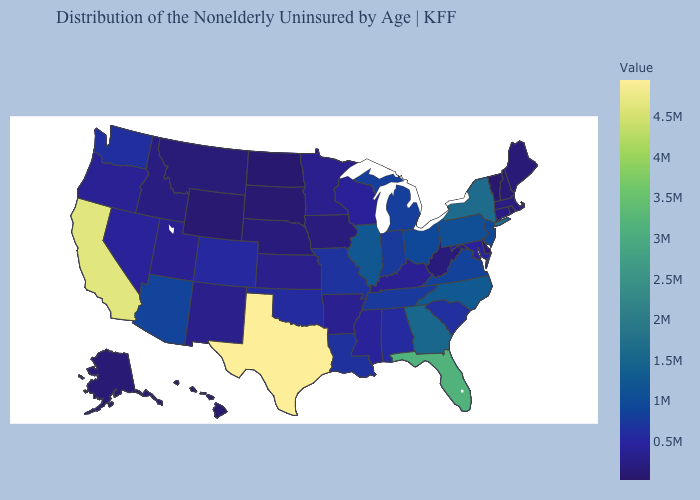Does Tennessee have the lowest value in the USA?
Short answer required. No. Among the states that border Maryland , which have the lowest value?
Concise answer only. Delaware. Among the states that border Illinois , does Kentucky have the highest value?
Give a very brief answer. No. Among the states that border Mississippi , does Arkansas have the lowest value?
Write a very short answer. Yes. Is the legend a continuous bar?
Be succinct. Yes. Does New York have a higher value than Florida?
Give a very brief answer. No. Does Vermont have the lowest value in the USA?
Quick response, please. Yes. 